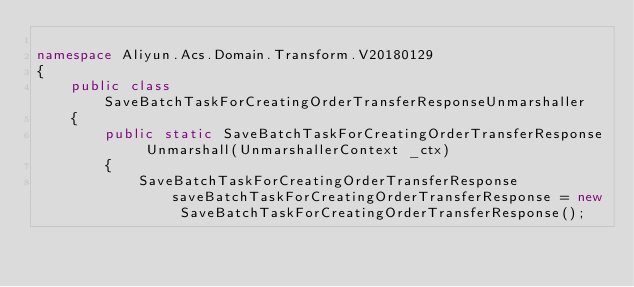Convert code to text. <code><loc_0><loc_0><loc_500><loc_500><_C#_>
namespace Aliyun.Acs.Domain.Transform.V20180129
{
    public class SaveBatchTaskForCreatingOrderTransferResponseUnmarshaller
    {
        public static SaveBatchTaskForCreatingOrderTransferResponse Unmarshall(UnmarshallerContext _ctx)
        {
			SaveBatchTaskForCreatingOrderTransferResponse saveBatchTaskForCreatingOrderTransferResponse = new SaveBatchTaskForCreatingOrderTransferResponse();
</code> 